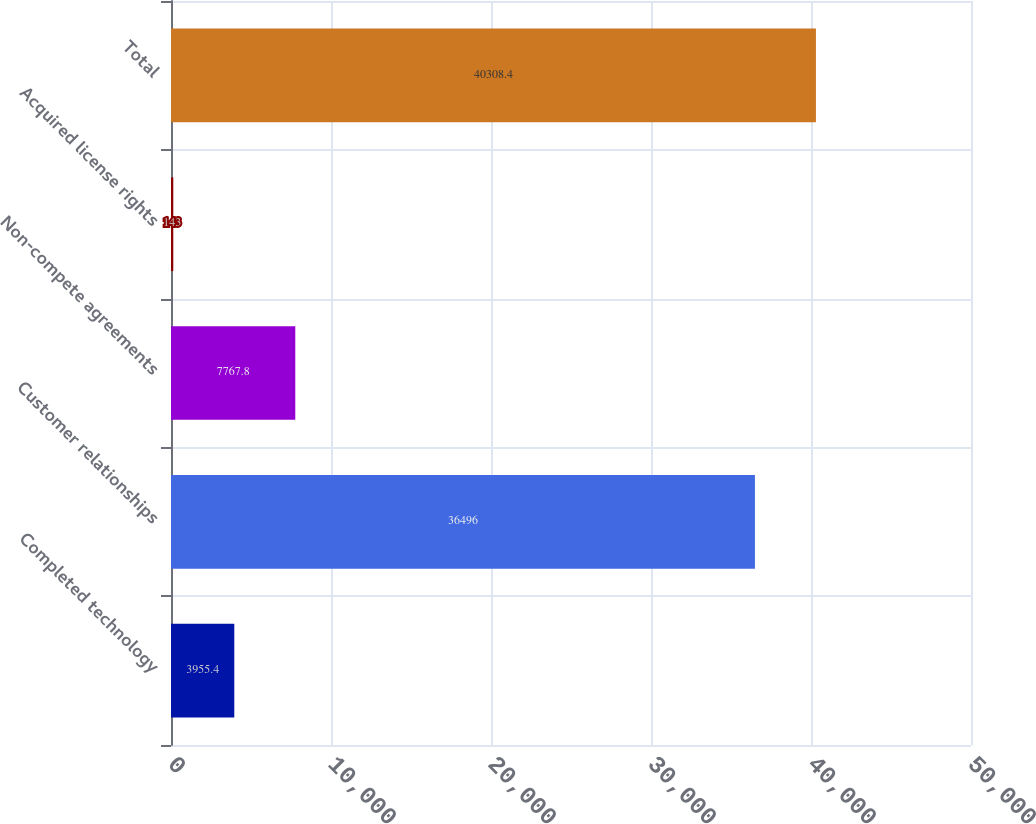<chart> <loc_0><loc_0><loc_500><loc_500><bar_chart><fcel>Completed technology<fcel>Customer relationships<fcel>Non-compete agreements<fcel>Acquired license rights<fcel>Total<nl><fcel>3955.4<fcel>36496<fcel>7767.8<fcel>143<fcel>40308.4<nl></chart> 